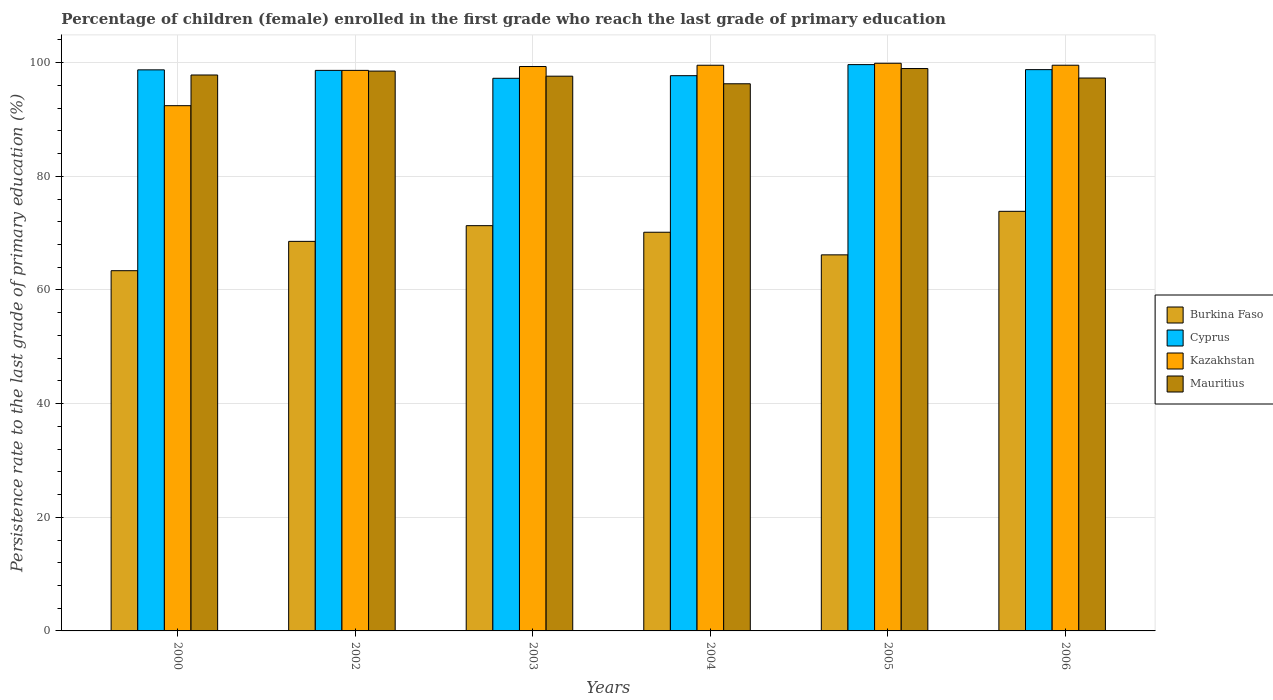How many different coloured bars are there?
Ensure brevity in your answer.  4. How many groups of bars are there?
Offer a terse response. 6. How many bars are there on the 4th tick from the left?
Your response must be concise. 4. What is the persistence rate of children in Mauritius in 2003?
Make the answer very short. 97.62. Across all years, what is the maximum persistence rate of children in Kazakhstan?
Give a very brief answer. 99.9. Across all years, what is the minimum persistence rate of children in Burkina Faso?
Give a very brief answer. 63.39. In which year was the persistence rate of children in Cyprus maximum?
Give a very brief answer. 2005. In which year was the persistence rate of children in Kazakhstan minimum?
Keep it short and to the point. 2000. What is the total persistence rate of children in Kazakhstan in the graph?
Offer a terse response. 589.4. What is the difference between the persistence rate of children in Kazakhstan in 2002 and that in 2006?
Ensure brevity in your answer.  -0.91. What is the difference between the persistence rate of children in Burkina Faso in 2003 and the persistence rate of children in Kazakhstan in 2005?
Your answer should be very brief. -28.58. What is the average persistence rate of children in Burkina Faso per year?
Ensure brevity in your answer.  68.91. In the year 2006, what is the difference between the persistence rate of children in Cyprus and persistence rate of children in Mauritius?
Keep it short and to the point. 1.48. In how many years, is the persistence rate of children in Cyprus greater than 16 %?
Provide a short and direct response. 6. What is the ratio of the persistence rate of children in Mauritius in 2002 to that in 2005?
Give a very brief answer. 1. Is the persistence rate of children in Kazakhstan in 2002 less than that in 2005?
Offer a very short reply. Yes. What is the difference between the highest and the second highest persistence rate of children in Kazakhstan?
Offer a very short reply. 0.35. What is the difference between the highest and the lowest persistence rate of children in Kazakhstan?
Make the answer very short. 7.46. In how many years, is the persistence rate of children in Cyprus greater than the average persistence rate of children in Cyprus taken over all years?
Keep it short and to the point. 4. Is the sum of the persistence rate of children in Cyprus in 2002 and 2006 greater than the maximum persistence rate of children in Mauritius across all years?
Your answer should be compact. Yes. What does the 1st bar from the left in 2002 represents?
Give a very brief answer. Burkina Faso. What does the 4th bar from the right in 2002 represents?
Your answer should be compact. Burkina Faso. Is it the case that in every year, the sum of the persistence rate of children in Kazakhstan and persistence rate of children in Burkina Faso is greater than the persistence rate of children in Mauritius?
Offer a terse response. Yes. Are all the bars in the graph horizontal?
Offer a terse response. No. What is the difference between two consecutive major ticks on the Y-axis?
Give a very brief answer. 20. Are the values on the major ticks of Y-axis written in scientific E-notation?
Ensure brevity in your answer.  No. How many legend labels are there?
Make the answer very short. 4. What is the title of the graph?
Ensure brevity in your answer.  Percentage of children (female) enrolled in the first grade who reach the last grade of primary education. Does "Dominican Republic" appear as one of the legend labels in the graph?
Offer a terse response. No. What is the label or title of the Y-axis?
Give a very brief answer. Persistence rate to the last grade of primary education (%). What is the Persistence rate to the last grade of primary education (%) of Burkina Faso in 2000?
Give a very brief answer. 63.39. What is the Persistence rate to the last grade of primary education (%) of Cyprus in 2000?
Give a very brief answer. 98.74. What is the Persistence rate to the last grade of primary education (%) of Kazakhstan in 2000?
Make the answer very short. 92.43. What is the Persistence rate to the last grade of primary education (%) in Mauritius in 2000?
Your response must be concise. 97.83. What is the Persistence rate to the last grade of primary education (%) in Burkina Faso in 2002?
Make the answer very short. 68.55. What is the Persistence rate to the last grade of primary education (%) in Cyprus in 2002?
Offer a terse response. 98.64. What is the Persistence rate to the last grade of primary education (%) in Kazakhstan in 2002?
Make the answer very short. 98.65. What is the Persistence rate to the last grade of primary education (%) in Mauritius in 2002?
Your answer should be very brief. 98.52. What is the Persistence rate to the last grade of primary education (%) in Burkina Faso in 2003?
Offer a very short reply. 71.32. What is the Persistence rate to the last grade of primary education (%) in Cyprus in 2003?
Make the answer very short. 97.25. What is the Persistence rate to the last grade of primary education (%) of Kazakhstan in 2003?
Your answer should be very brief. 99.32. What is the Persistence rate to the last grade of primary education (%) of Mauritius in 2003?
Give a very brief answer. 97.62. What is the Persistence rate to the last grade of primary education (%) in Burkina Faso in 2004?
Your response must be concise. 70.16. What is the Persistence rate to the last grade of primary education (%) of Cyprus in 2004?
Keep it short and to the point. 97.71. What is the Persistence rate to the last grade of primary education (%) in Kazakhstan in 2004?
Provide a succinct answer. 99.55. What is the Persistence rate to the last grade of primary education (%) of Mauritius in 2004?
Give a very brief answer. 96.29. What is the Persistence rate to the last grade of primary education (%) of Burkina Faso in 2005?
Provide a succinct answer. 66.18. What is the Persistence rate to the last grade of primary education (%) in Cyprus in 2005?
Keep it short and to the point. 99.66. What is the Persistence rate to the last grade of primary education (%) of Kazakhstan in 2005?
Provide a short and direct response. 99.9. What is the Persistence rate to the last grade of primary education (%) in Mauritius in 2005?
Give a very brief answer. 98.97. What is the Persistence rate to the last grade of primary education (%) of Burkina Faso in 2006?
Offer a very short reply. 73.84. What is the Persistence rate to the last grade of primary education (%) of Cyprus in 2006?
Offer a terse response. 98.78. What is the Persistence rate to the last grade of primary education (%) in Kazakhstan in 2006?
Offer a terse response. 99.55. What is the Persistence rate to the last grade of primary education (%) in Mauritius in 2006?
Provide a short and direct response. 97.3. Across all years, what is the maximum Persistence rate to the last grade of primary education (%) in Burkina Faso?
Provide a short and direct response. 73.84. Across all years, what is the maximum Persistence rate to the last grade of primary education (%) in Cyprus?
Provide a succinct answer. 99.66. Across all years, what is the maximum Persistence rate to the last grade of primary education (%) of Kazakhstan?
Provide a short and direct response. 99.9. Across all years, what is the maximum Persistence rate to the last grade of primary education (%) in Mauritius?
Keep it short and to the point. 98.97. Across all years, what is the minimum Persistence rate to the last grade of primary education (%) of Burkina Faso?
Provide a short and direct response. 63.39. Across all years, what is the minimum Persistence rate to the last grade of primary education (%) of Cyprus?
Keep it short and to the point. 97.25. Across all years, what is the minimum Persistence rate to the last grade of primary education (%) in Kazakhstan?
Your response must be concise. 92.43. Across all years, what is the minimum Persistence rate to the last grade of primary education (%) in Mauritius?
Provide a short and direct response. 96.29. What is the total Persistence rate to the last grade of primary education (%) of Burkina Faso in the graph?
Ensure brevity in your answer.  413.45. What is the total Persistence rate to the last grade of primary education (%) in Cyprus in the graph?
Your response must be concise. 590.79. What is the total Persistence rate to the last grade of primary education (%) in Kazakhstan in the graph?
Your answer should be compact. 589.4. What is the total Persistence rate to the last grade of primary education (%) of Mauritius in the graph?
Make the answer very short. 586.54. What is the difference between the Persistence rate to the last grade of primary education (%) in Burkina Faso in 2000 and that in 2002?
Your answer should be very brief. -5.16. What is the difference between the Persistence rate to the last grade of primary education (%) in Cyprus in 2000 and that in 2002?
Provide a short and direct response. 0.09. What is the difference between the Persistence rate to the last grade of primary education (%) of Kazakhstan in 2000 and that in 2002?
Give a very brief answer. -6.21. What is the difference between the Persistence rate to the last grade of primary education (%) of Mauritius in 2000 and that in 2002?
Your answer should be compact. -0.69. What is the difference between the Persistence rate to the last grade of primary education (%) in Burkina Faso in 2000 and that in 2003?
Offer a very short reply. -7.93. What is the difference between the Persistence rate to the last grade of primary education (%) of Cyprus in 2000 and that in 2003?
Provide a short and direct response. 1.48. What is the difference between the Persistence rate to the last grade of primary education (%) of Kazakhstan in 2000 and that in 2003?
Your response must be concise. -6.89. What is the difference between the Persistence rate to the last grade of primary education (%) in Mauritius in 2000 and that in 2003?
Offer a terse response. 0.21. What is the difference between the Persistence rate to the last grade of primary education (%) of Burkina Faso in 2000 and that in 2004?
Your answer should be compact. -6.77. What is the difference between the Persistence rate to the last grade of primary education (%) in Cyprus in 2000 and that in 2004?
Provide a short and direct response. 1.02. What is the difference between the Persistence rate to the last grade of primary education (%) in Kazakhstan in 2000 and that in 2004?
Keep it short and to the point. -7.12. What is the difference between the Persistence rate to the last grade of primary education (%) of Mauritius in 2000 and that in 2004?
Provide a short and direct response. 1.54. What is the difference between the Persistence rate to the last grade of primary education (%) of Burkina Faso in 2000 and that in 2005?
Offer a terse response. -2.79. What is the difference between the Persistence rate to the last grade of primary education (%) of Cyprus in 2000 and that in 2005?
Offer a terse response. -0.92. What is the difference between the Persistence rate to the last grade of primary education (%) in Kazakhstan in 2000 and that in 2005?
Ensure brevity in your answer.  -7.46. What is the difference between the Persistence rate to the last grade of primary education (%) in Mauritius in 2000 and that in 2005?
Your response must be concise. -1.14. What is the difference between the Persistence rate to the last grade of primary education (%) in Burkina Faso in 2000 and that in 2006?
Make the answer very short. -10.45. What is the difference between the Persistence rate to the last grade of primary education (%) in Cyprus in 2000 and that in 2006?
Give a very brief answer. -0.04. What is the difference between the Persistence rate to the last grade of primary education (%) of Kazakhstan in 2000 and that in 2006?
Your answer should be very brief. -7.12. What is the difference between the Persistence rate to the last grade of primary education (%) of Mauritius in 2000 and that in 2006?
Give a very brief answer. 0.53. What is the difference between the Persistence rate to the last grade of primary education (%) in Burkina Faso in 2002 and that in 2003?
Keep it short and to the point. -2.77. What is the difference between the Persistence rate to the last grade of primary education (%) in Cyprus in 2002 and that in 2003?
Offer a terse response. 1.39. What is the difference between the Persistence rate to the last grade of primary education (%) of Kazakhstan in 2002 and that in 2003?
Give a very brief answer. -0.68. What is the difference between the Persistence rate to the last grade of primary education (%) of Mauritius in 2002 and that in 2003?
Your answer should be compact. 0.9. What is the difference between the Persistence rate to the last grade of primary education (%) of Burkina Faso in 2002 and that in 2004?
Your response must be concise. -1.61. What is the difference between the Persistence rate to the last grade of primary education (%) in Cyprus in 2002 and that in 2004?
Your answer should be compact. 0.93. What is the difference between the Persistence rate to the last grade of primary education (%) of Kazakhstan in 2002 and that in 2004?
Offer a terse response. -0.9. What is the difference between the Persistence rate to the last grade of primary education (%) in Mauritius in 2002 and that in 2004?
Your answer should be very brief. 2.23. What is the difference between the Persistence rate to the last grade of primary education (%) in Burkina Faso in 2002 and that in 2005?
Give a very brief answer. 2.37. What is the difference between the Persistence rate to the last grade of primary education (%) of Cyprus in 2002 and that in 2005?
Provide a short and direct response. -1.01. What is the difference between the Persistence rate to the last grade of primary education (%) of Kazakhstan in 2002 and that in 2005?
Offer a very short reply. -1.25. What is the difference between the Persistence rate to the last grade of primary education (%) in Mauritius in 2002 and that in 2005?
Ensure brevity in your answer.  -0.45. What is the difference between the Persistence rate to the last grade of primary education (%) in Burkina Faso in 2002 and that in 2006?
Your answer should be compact. -5.29. What is the difference between the Persistence rate to the last grade of primary education (%) in Cyprus in 2002 and that in 2006?
Offer a very short reply. -0.13. What is the difference between the Persistence rate to the last grade of primary education (%) of Kazakhstan in 2002 and that in 2006?
Provide a succinct answer. -0.91. What is the difference between the Persistence rate to the last grade of primary education (%) in Mauritius in 2002 and that in 2006?
Provide a short and direct response. 1.22. What is the difference between the Persistence rate to the last grade of primary education (%) of Burkina Faso in 2003 and that in 2004?
Offer a terse response. 1.16. What is the difference between the Persistence rate to the last grade of primary education (%) of Cyprus in 2003 and that in 2004?
Offer a very short reply. -0.46. What is the difference between the Persistence rate to the last grade of primary education (%) in Kazakhstan in 2003 and that in 2004?
Your answer should be very brief. -0.23. What is the difference between the Persistence rate to the last grade of primary education (%) in Mauritius in 2003 and that in 2004?
Give a very brief answer. 1.33. What is the difference between the Persistence rate to the last grade of primary education (%) of Burkina Faso in 2003 and that in 2005?
Provide a short and direct response. 5.14. What is the difference between the Persistence rate to the last grade of primary education (%) of Cyprus in 2003 and that in 2005?
Ensure brevity in your answer.  -2.41. What is the difference between the Persistence rate to the last grade of primary education (%) in Kazakhstan in 2003 and that in 2005?
Ensure brevity in your answer.  -0.58. What is the difference between the Persistence rate to the last grade of primary education (%) of Mauritius in 2003 and that in 2005?
Your answer should be very brief. -1.35. What is the difference between the Persistence rate to the last grade of primary education (%) of Burkina Faso in 2003 and that in 2006?
Your answer should be compact. -2.52. What is the difference between the Persistence rate to the last grade of primary education (%) of Cyprus in 2003 and that in 2006?
Provide a short and direct response. -1.52. What is the difference between the Persistence rate to the last grade of primary education (%) of Kazakhstan in 2003 and that in 2006?
Ensure brevity in your answer.  -0.23. What is the difference between the Persistence rate to the last grade of primary education (%) of Mauritius in 2003 and that in 2006?
Make the answer very short. 0.33. What is the difference between the Persistence rate to the last grade of primary education (%) in Burkina Faso in 2004 and that in 2005?
Your answer should be very brief. 3.98. What is the difference between the Persistence rate to the last grade of primary education (%) in Cyprus in 2004 and that in 2005?
Keep it short and to the point. -1.95. What is the difference between the Persistence rate to the last grade of primary education (%) in Kazakhstan in 2004 and that in 2005?
Keep it short and to the point. -0.35. What is the difference between the Persistence rate to the last grade of primary education (%) in Mauritius in 2004 and that in 2005?
Ensure brevity in your answer.  -2.68. What is the difference between the Persistence rate to the last grade of primary education (%) in Burkina Faso in 2004 and that in 2006?
Ensure brevity in your answer.  -3.68. What is the difference between the Persistence rate to the last grade of primary education (%) of Cyprus in 2004 and that in 2006?
Provide a short and direct response. -1.06. What is the difference between the Persistence rate to the last grade of primary education (%) of Kazakhstan in 2004 and that in 2006?
Make the answer very short. -0. What is the difference between the Persistence rate to the last grade of primary education (%) of Mauritius in 2004 and that in 2006?
Offer a very short reply. -1.01. What is the difference between the Persistence rate to the last grade of primary education (%) of Burkina Faso in 2005 and that in 2006?
Make the answer very short. -7.66. What is the difference between the Persistence rate to the last grade of primary education (%) in Cyprus in 2005 and that in 2006?
Keep it short and to the point. 0.88. What is the difference between the Persistence rate to the last grade of primary education (%) in Kazakhstan in 2005 and that in 2006?
Provide a short and direct response. 0.35. What is the difference between the Persistence rate to the last grade of primary education (%) of Mauritius in 2005 and that in 2006?
Offer a terse response. 1.67. What is the difference between the Persistence rate to the last grade of primary education (%) in Burkina Faso in 2000 and the Persistence rate to the last grade of primary education (%) in Cyprus in 2002?
Offer a terse response. -35.25. What is the difference between the Persistence rate to the last grade of primary education (%) of Burkina Faso in 2000 and the Persistence rate to the last grade of primary education (%) of Kazakhstan in 2002?
Give a very brief answer. -35.25. What is the difference between the Persistence rate to the last grade of primary education (%) of Burkina Faso in 2000 and the Persistence rate to the last grade of primary education (%) of Mauritius in 2002?
Ensure brevity in your answer.  -35.13. What is the difference between the Persistence rate to the last grade of primary education (%) of Cyprus in 2000 and the Persistence rate to the last grade of primary education (%) of Kazakhstan in 2002?
Ensure brevity in your answer.  0.09. What is the difference between the Persistence rate to the last grade of primary education (%) of Cyprus in 2000 and the Persistence rate to the last grade of primary education (%) of Mauritius in 2002?
Keep it short and to the point. 0.21. What is the difference between the Persistence rate to the last grade of primary education (%) in Kazakhstan in 2000 and the Persistence rate to the last grade of primary education (%) in Mauritius in 2002?
Keep it short and to the point. -6.09. What is the difference between the Persistence rate to the last grade of primary education (%) of Burkina Faso in 2000 and the Persistence rate to the last grade of primary education (%) of Cyprus in 2003?
Keep it short and to the point. -33.86. What is the difference between the Persistence rate to the last grade of primary education (%) of Burkina Faso in 2000 and the Persistence rate to the last grade of primary education (%) of Kazakhstan in 2003?
Offer a very short reply. -35.93. What is the difference between the Persistence rate to the last grade of primary education (%) in Burkina Faso in 2000 and the Persistence rate to the last grade of primary education (%) in Mauritius in 2003?
Give a very brief answer. -34.23. What is the difference between the Persistence rate to the last grade of primary education (%) in Cyprus in 2000 and the Persistence rate to the last grade of primary education (%) in Kazakhstan in 2003?
Give a very brief answer. -0.59. What is the difference between the Persistence rate to the last grade of primary education (%) in Cyprus in 2000 and the Persistence rate to the last grade of primary education (%) in Mauritius in 2003?
Provide a succinct answer. 1.11. What is the difference between the Persistence rate to the last grade of primary education (%) in Kazakhstan in 2000 and the Persistence rate to the last grade of primary education (%) in Mauritius in 2003?
Offer a terse response. -5.19. What is the difference between the Persistence rate to the last grade of primary education (%) in Burkina Faso in 2000 and the Persistence rate to the last grade of primary education (%) in Cyprus in 2004?
Ensure brevity in your answer.  -34.32. What is the difference between the Persistence rate to the last grade of primary education (%) of Burkina Faso in 2000 and the Persistence rate to the last grade of primary education (%) of Kazakhstan in 2004?
Provide a short and direct response. -36.16. What is the difference between the Persistence rate to the last grade of primary education (%) in Burkina Faso in 2000 and the Persistence rate to the last grade of primary education (%) in Mauritius in 2004?
Make the answer very short. -32.9. What is the difference between the Persistence rate to the last grade of primary education (%) in Cyprus in 2000 and the Persistence rate to the last grade of primary education (%) in Kazakhstan in 2004?
Make the answer very short. -0.81. What is the difference between the Persistence rate to the last grade of primary education (%) of Cyprus in 2000 and the Persistence rate to the last grade of primary education (%) of Mauritius in 2004?
Provide a succinct answer. 2.45. What is the difference between the Persistence rate to the last grade of primary education (%) of Kazakhstan in 2000 and the Persistence rate to the last grade of primary education (%) of Mauritius in 2004?
Your answer should be compact. -3.86. What is the difference between the Persistence rate to the last grade of primary education (%) of Burkina Faso in 2000 and the Persistence rate to the last grade of primary education (%) of Cyprus in 2005?
Make the answer very short. -36.27. What is the difference between the Persistence rate to the last grade of primary education (%) in Burkina Faso in 2000 and the Persistence rate to the last grade of primary education (%) in Kazakhstan in 2005?
Ensure brevity in your answer.  -36.51. What is the difference between the Persistence rate to the last grade of primary education (%) of Burkina Faso in 2000 and the Persistence rate to the last grade of primary education (%) of Mauritius in 2005?
Ensure brevity in your answer.  -35.58. What is the difference between the Persistence rate to the last grade of primary education (%) in Cyprus in 2000 and the Persistence rate to the last grade of primary education (%) in Kazakhstan in 2005?
Offer a terse response. -1.16. What is the difference between the Persistence rate to the last grade of primary education (%) of Cyprus in 2000 and the Persistence rate to the last grade of primary education (%) of Mauritius in 2005?
Give a very brief answer. -0.23. What is the difference between the Persistence rate to the last grade of primary education (%) in Kazakhstan in 2000 and the Persistence rate to the last grade of primary education (%) in Mauritius in 2005?
Keep it short and to the point. -6.54. What is the difference between the Persistence rate to the last grade of primary education (%) of Burkina Faso in 2000 and the Persistence rate to the last grade of primary education (%) of Cyprus in 2006?
Your answer should be very brief. -35.38. What is the difference between the Persistence rate to the last grade of primary education (%) in Burkina Faso in 2000 and the Persistence rate to the last grade of primary education (%) in Kazakhstan in 2006?
Offer a terse response. -36.16. What is the difference between the Persistence rate to the last grade of primary education (%) in Burkina Faso in 2000 and the Persistence rate to the last grade of primary education (%) in Mauritius in 2006?
Your response must be concise. -33.91. What is the difference between the Persistence rate to the last grade of primary education (%) in Cyprus in 2000 and the Persistence rate to the last grade of primary education (%) in Kazakhstan in 2006?
Provide a succinct answer. -0.81. What is the difference between the Persistence rate to the last grade of primary education (%) of Cyprus in 2000 and the Persistence rate to the last grade of primary education (%) of Mauritius in 2006?
Give a very brief answer. 1.44. What is the difference between the Persistence rate to the last grade of primary education (%) in Kazakhstan in 2000 and the Persistence rate to the last grade of primary education (%) in Mauritius in 2006?
Make the answer very short. -4.86. What is the difference between the Persistence rate to the last grade of primary education (%) of Burkina Faso in 2002 and the Persistence rate to the last grade of primary education (%) of Cyprus in 2003?
Provide a short and direct response. -28.7. What is the difference between the Persistence rate to the last grade of primary education (%) in Burkina Faso in 2002 and the Persistence rate to the last grade of primary education (%) in Kazakhstan in 2003?
Your response must be concise. -30.77. What is the difference between the Persistence rate to the last grade of primary education (%) of Burkina Faso in 2002 and the Persistence rate to the last grade of primary education (%) of Mauritius in 2003?
Provide a short and direct response. -29.07. What is the difference between the Persistence rate to the last grade of primary education (%) in Cyprus in 2002 and the Persistence rate to the last grade of primary education (%) in Kazakhstan in 2003?
Give a very brief answer. -0.68. What is the difference between the Persistence rate to the last grade of primary education (%) of Cyprus in 2002 and the Persistence rate to the last grade of primary education (%) of Mauritius in 2003?
Your answer should be very brief. 1.02. What is the difference between the Persistence rate to the last grade of primary education (%) of Kazakhstan in 2002 and the Persistence rate to the last grade of primary education (%) of Mauritius in 2003?
Provide a short and direct response. 1.02. What is the difference between the Persistence rate to the last grade of primary education (%) of Burkina Faso in 2002 and the Persistence rate to the last grade of primary education (%) of Cyprus in 2004?
Your answer should be compact. -29.16. What is the difference between the Persistence rate to the last grade of primary education (%) in Burkina Faso in 2002 and the Persistence rate to the last grade of primary education (%) in Kazakhstan in 2004?
Your answer should be very brief. -31. What is the difference between the Persistence rate to the last grade of primary education (%) of Burkina Faso in 2002 and the Persistence rate to the last grade of primary education (%) of Mauritius in 2004?
Provide a short and direct response. -27.74. What is the difference between the Persistence rate to the last grade of primary education (%) of Cyprus in 2002 and the Persistence rate to the last grade of primary education (%) of Kazakhstan in 2004?
Your response must be concise. -0.91. What is the difference between the Persistence rate to the last grade of primary education (%) in Cyprus in 2002 and the Persistence rate to the last grade of primary education (%) in Mauritius in 2004?
Your response must be concise. 2.36. What is the difference between the Persistence rate to the last grade of primary education (%) in Kazakhstan in 2002 and the Persistence rate to the last grade of primary education (%) in Mauritius in 2004?
Make the answer very short. 2.36. What is the difference between the Persistence rate to the last grade of primary education (%) in Burkina Faso in 2002 and the Persistence rate to the last grade of primary education (%) in Cyprus in 2005?
Make the answer very short. -31.11. What is the difference between the Persistence rate to the last grade of primary education (%) of Burkina Faso in 2002 and the Persistence rate to the last grade of primary education (%) of Kazakhstan in 2005?
Ensure brevity in your answer.  -31.34. What is the difference between the Persistence rate to the last grade of primary education (%) of Burkina Faso in 2002 and the Persistence rate to the last grade of primary education (%) of Mauritius in 2005?
Provide a succinct answer. -30.42. What is the difference between the Persistence rate to the last grade of primary education (%) of Cyprus in 2002 and the Persistence rate to the last grade of primary education (%) of Kazakhstan in 2005?
Ensure brevity in your answer.  -1.25. What is the difference between the Persistence rate to the last grade of primary education (%) in Cyprus in 2002 and the Persistence rate to the last grade of primary education (%) in Mauritius in 2005?
Provide a short and direct response. -0.33. What is the difference between the Persistence rate to the last grade of primary education (%) of Kazakhstan in 2002 and the Persistence rate to the last grade of primary education (%) of Mauritius in 2005?
Keep it short and to the point. -0.32. What is the difference between the Persistence rate to the last grade of primary education (%) of Burkina Faso in 2002 and the Persistence rate to the last grade of primary education (%) of Cyprus in 2006?
Make the answer very short. -30.22. What is the difference between the Persistence rate to the last grade of primary education (%) in Burkina Faso in 2002 and the Persistence rate to the last grade of primary education (%) in Kazakhstan in 2006?
Ensure brevity in your answer.  -31. What is the difference between the Persistence rate to the last grade of primary education (%) in Burkina Faso in 2002 and the Persistence rate to the last grade of primary education (%) in Mauritius in 2006?
Keep it short and to the point. -28.74. What is the difference between the Persistence rate to the last grade of primary education (%) of Cyprus in 2002 and the Persistence rate to the last grade of primary education (%) of Kazakhstan in 2006?
Offer a very short reply. -0.91. What is the difference between the Persistence rate to the last grade of primary education (%) in Cyprus in 2002 and the Persistence rate to the last grade of primary education (%) in Mauritius in 2006?
Your answer should be compact. 1.35. What is the difference between the Persistence rate to the last grade of primary education (%) in Kazakhstan in 2002 and the Persistence rate to the last grade of primary education (%) in Mauritius in 2006?
Ensure brevity in your answer.  1.35. What is the difference between the Persistence rate to the last grade of primary education (%) of Burkina Faso in 2003 and the Persistence rate to the last grade of primary education (%) of Cyprus in 2004?
Provide a short and direct response. -26.39. What is the difference between the Persistence rate to the last grade of primary education (%) in Burkina Faso in 2003 and the Persistence rate to the last grade of primary education (%) in Kazakhstan in 2004?
Your answer should be compact. -28.23. What is the difference between the Persistence rate to the last grade of primary education (%) of Burkina Faso in 2003 and the Persistence rate to the last grade of primary education (%) of Mauritius in 2004?
Your answer should be compact. -24.97. What is the difference between the Persistence rate to the last grade of primary education (%) in Cyprus in 2003 and the Persistence rate to the last grade of primary education (%) in Kazakhstan in 2004?
Keep it short and to the point. -2.3. What is the difference between the Persistence rate to the last grade of primary education (%) in Cyprus in 2003 and the Persistence rate to the last grade of primary education (%) in Mauritius in 2004?
Make the answer very short. 0.96. What is the difference between the Persistence rate to the last grade of primary education (%) of Kazakhstan in 2003 and the Persistence rate to the last grade of primary education (%) of Mauritius in 2004?
Provide a succinct answer. 3.03. What is the difference between the Persistence rate to the last grade of primary education (%) in Burkina Faso in 2003 and the Persistence rate to the last grade of primary education (%) in Cyprus in 2005?
Provide a succinct answer. -28.34. What is the difference between the Persistence rate to the last grade of primary education (%) of Burkina Faso in 2003 and the Persistence rate to the last grade of primary education (%) of Kazakhstan in 2005?
Offer a terse response. -28.58. What is the difference between the Persistence rate to the last grade of primary education (%) in Burkina Faso in 2003 and the Persistence rate to the last grade of primary education (%) in Mauritius in 2005?
Keep it short and to the point. -27.65. What is the difference between the Persistence rate to the last grade of primary education (%) of Cyprus in 2003 and the Persistence rate to the last grade of primary education (%) of Kazakhstan in 2005?
Your answer should be compact. -2.65. What is the difference between the Persistence rate to the last grade of primary education (%) of Cyprus in 2003 and the Persistence rate to the last grade of primary education (%) of Mauritius in 2005?
Offer a terse response. -1.72. What is the difference between the Persistence rate to the last grade of primary education (%) of Kazakhstan in 2003 and the Persistence rate to the last grade of primary education (%) of Mauritius in 2005?
Provide a short and direct response. 0.35. What is the difference between the Persistence rate to the last grade of primary education (%) of Burkina Faso in 2003 and the Persistence rate to the last grade of primary education (%) of Cyprus in 2006?
Your answer should be compact. -27.46. What is the difference between the Persistence rate to the last grade of primary education (%) in Burkina Faso in 2003 and the Persistence rate to the last grade of primary education (%) in Kazakhstan in 2006?
Your answer should be very brief. -28.23. What is the difference between the Persistence rate to the last grade of primary education (%) of Burkina Faso in 2003 and the Persistence rate to the last grade of primary education (%) of Mauritius in 2006?
Make the answer very short. -25.98. What is the difference between the Persistence rate to the last grade of primary education (%) of Cyprus in 2003 and the Persistence rate to the last grade of primary education (%) of Kazakhstan in 2006?
Offer a very short reply. -2.3. What is the difference between the Persistence rate to the last grade of primary education (%) in Cyprus in 2003 and the Persistence rate to the last grade of primary education (%) in Mauritius in 2006?
Give a very brief answer. -0.05. What is the difference between the Persistence rate to the last grade of primary education (%) in Kazakhstan in 2003 and the Persistence rate to the last grade of primary education (%) in Mauritius in 2006?
Keep it short and to the point. 2.02. What is the difference between the Persistence rate to the last grade of primary education (%) in Burkina Faso in 2004 and the Persistence rate to the last grade of primary education (%) in Cyprus in 2005?
Your response must be concise. -29.5. What is the difference between the Persistence rate to the last grade of primary education (%) of Burkina Faso in 2004 and the Persistence rate to the last grade of primary education (%) of Kazakhstan in 2005?
Provide a succinct answer. -29.74. What is the difference between the Persistence rate to the last grade of primary education (%) in Burkina Faso in 2004 and the Persistence rate to the last grade of primary education (%) in Mauritius in 2005?
Offer a very short reply. -28.81. What is the difference between the Persistence rate to the last grade of primary education (%) in Cyprus in 2004 and the Persistence rate to the last grade of primary education (%) in Kazakhstan in 2005?
Give a very brief answer. -2.19. What is the difference between the Persistence rate to the last grade of primary education (%) of Cyprus in 2004 and the Persistence rate to the last grade of primary education (%) of Mauritius in 2005?
Ensure brevity in your answer.  -1.26. What is the difference between the Persistence rate to the last grade of primary education (%) in Kazakhstan in 2004 and the Persistence rate to the last grade of primary education (%) in Mauritius in 2005?
Your response must be concise. 0.58. What is the difference between the Persistence rate to the last grade of primary education (%) of Burkina Faso in 2004 and the Persistence rate to the last grade of primary education (%) of Cyprus in 2006?
Provide a succinct answer. -28.62. What is the difference between the Persistence rate to the last grade of primary education (%) of Burkina Faso in 2004 and the Persistence rate to the last grade of primary education (%) of Kazakhstan in 2006?
Provide a succinct answer. -29.39. What is the difference between the Persistence rate to the last grade of primary education (%) in Burkina Faso in 2004 and the Persistence rate to the last grade of primary education (%) in Mauritius in 2006?
Your answer should be compact. -27.14. What is the difference between the Persistence rate to the last grade of primary education (%) of Cyprus in 2004 and the Persistence rate to the last grade of primary education (%) of Kazakhstan in 2006?
Offer a very short reply. -1.84. What is the difference between the Persistence rate to the last grade of primary education (%) of Cyprus in 2004 and the Persistence rate to the last grade of primary education (%) of Mauritius in 2006?
Give a very brief answer. 0.41. What is the difference between the Persistence rate to the last grade of primary education (%) of Kazakhstan in 2004 and the Persistence rate to the last grade of primary education (%) of Mauritius in 2006?
Offer a very short reply. 2.25. What is the difference between the Persistence rate to the last grade of primary education (%) in Burkina Faso in 2005 and the Persistence rate to the last grade of primary education (%) in Cyprus in 2006?
Offer a very short reply. -32.6. What is the difference between the Persistence rate to the last grade of primary education (%) of Burkina Faso in 2005 and the Persistence rate to the last grade of primary education (%) of Kazakhstan in 2006?
Ensure brevity in your answer.  -33.37. What is the difference between the Persistence rate to the last grade of primary education (%) of Burkina Faso in 2005 and the Persistence rate to the last grade of primary education (%) of Mauritius in 2006?
Provide a succinct answer. -31.12. What is the difference between the Persistence rate to the last grade of primary education (%) of Cyprus in 2005 and the Persistence rate to the last grade of primary education (%) of Kazakhstan in 2006?
Your answer should be very brief. 0.11. What is the difference between the Persistence rate to the last grade of primary education (%) in Cyprus in 2005 and the Persistence rate to the last grade of primary education (%) in Mauritius in 2006?
Keep it short and to the point. 2.36. What is the difference between the Persistence rate to the last grade of primary education (%) in Kazakhstan in 2005 and the Persistence rate to the last grade of primary education (%) in Mauritius in 2006?
Keep it short and to the point. 2.6. What is the average Persistence rate to the last grade of primary education (%) of Burkina Faso per year?
Ensure brevity in your answer.  68.91. What is the average Persistence rate to the last grade of primary education (%) of Cyprus per year?
Provide a short and direct response. 98.46. What is the average Persistence rate to the last grade of primary education (%) in Kazakhstan per year?
Your answer should be compact. 98.23. What is the average Persistence rate to the last grade of primary education (%) of Mauritius per year?
Offer a very short reply. 97.76. In the year 2000, what is the difference between the Persistence rate to the last grade of primary education (%) of Burkina Faso and Persistence rate to the last grade of primary education (%) of Cyprus?
Ensure brevity in your answer.  -35.34. In the year 2000, what is the difference between the Persistence rate to the last grade of primary education (%) of Burkina Faso and Persistence rate to the last grade of primary education (%) of Kazakhstan?
Your answer should be compact. -29.04. In the year 2000, what is the difference between the Persistence rate to the last grade of primary education (%) in Burkina Faso and Persistence rate to the last grade of primary education (%) in Mauritius?
Make the answer very short. -34.44. In the year 2000, what is the difference between the Persistence rate to the last grade of primary education (%) in Cyprus and Persistence rate to the last grade of primary education (%) in Kazakhstan?
Offer a terse response. 6.3. In the year 2000, what is the difference between the Persistence rate to the last grade of primary education (%) of Cyprus and Persistence rate to the last grade of primary education (%) of Mauritius?
Provide a succinct answer. 0.9. In the year 2000, what is the difference between the Persistence rate to the last grade of primary education (%) of Kazakhstan and Persistence rate to the last grade of primary education (%) of Mauritius?
Make the answer very short. -5.4. In the year 2002, what is the difference between the Persistence rate to the last grade of primary education (%) in Burkina Faso and Persistence rate to the last grade of primary education (%) in Cyprus?
Your answer should be very brief. -30.09. In the year 2002, what is the difference between the Persistence rate to the last grade of primary education (%) in Burkina Faso and Persistence rate to the last grade of primary education (%) in Kazakhstan?
Ensure brevity in your answer.  -30.09. In the year 2002, what is the difference between the Persistence rate to the last grade of primary education (%) of Burkina Faso and Persistence rate to the last grade of primary education (%) of Mauritius?
Offer a terse response. -29.97. In the year 2002, what is the difference between the Persistence rate to the last grade of primary education (%) in Cyprus and Persistence rate to the last grade of primary education (%) in Kazakhstan?
Make the answer very short. -0. In the year 2002, what is the difference between the Persistence rate to the last grade of primary education (%) of Cyprus and Persistence rate to the last grade of primary education (%) of Mauritius?
Your answer should be compact. 0.12. In the year 2002, what is the difference between the Persistence rate to the last grade of primary education (%) in Kazakhstan and Persistence rate to the last grade of primary education (%) in Mauritius?
Make the answer very short. 0.12. In the year 2003, what is the difference between the Persistence rate to the last grade of primary education (%) of Burkina Faso and Persistence rate to the last grade of primary education (%) of Cyprus?
Provide a succinct answer. -25.93. In the year 2003, what is the difference between the Persistence rate to the last grade of primary education (%) of Burkina Faso and Persistence rate to the last grade of primary education (%) of Kazakhstan?
Provide a short and direct response. -28. In the year 2003, what is the difference between the Persistence rate to the last grade of primary education (%) of Burkina Faso and Persistence rate to the last grade of primary education (%) of Mauritius?
Your response must be concise. -26.3. In the year 2003, what is the difference between the Persistence rate to the last grade of primary education (%) of Cyprus and Persistence rate to the last grade of primary education (%) of Kazakhstan?
Provide a short and direct response. -2.07. In the year 2003, what is the difference between the Persistence rate to the last grade of primary education (%) in Cyprus and Persistence rate to the last grade of primary education (%) in Mauritius?
Your response must be concise. -0.37. In the year 2003, what is the difference between the Persistence rate to the last grade of primary education (%) in Kazakhstan and Persistence rate to the last grade of primary education (%) in Mauritius?
Your answer should be compact. 1.7. In the year 2004, what is the difference between the Persistence rate to the last grade of primary education (%) of Burkina Faso and Persistence rate to the last grade of primary education (%) of Cyprus?
Ensure brevity in your answer.  -27.55. In the year 2004, what is the difference between the Persistence rate to the last grade of primary education (%) in Burkina Faso and Persistence rate to the last grade of primary education (%) in Kazakhstan?
Ensure brevity in your answer.  -29.39. In the year 2004, what is the difference between the Persistence rate to the last grade of primary education (%) of Burkina Faso and Persistence rate to the last grade of primary education (%) of Mauritius?
Give a very brief answer. -26.13. In the year 2004, what is the difference between the Persistence rate to the last grade of primary education (%) of Cyprus and Persistence rate to the last grade of primary education (%) of Kazakhstan?
Offer a very short reply. -1.84. In the year 2004, what is the difference between the Persistence rate to the last grade of primary education (%) of Cyprus and Persistence rate to the last grade of primary education (%) of Mauritius?
Give a very brief answer. 1.42. In the year 2004, what is the difference between the Persistence rate to the last grade of primary education (%) in Kazakhstan and Persistence rate to the last grade of primary education (%) in Mauritius?
Offer a very short reply. 3.26. In the year 2005, what is the difference between the Persistence rate to the last grade of primary education (%) of Burkina Faso and Persistence rate to the last grade of primary education (%) of Cyprus?
Make the answer very short. -33.48. In the year 2005, what is the difference between the Persistence rate to the last grade of primary education (%) of Burkina Faso and Persistence rate to the last grade of primary education (%) of Kazakhstan?
Your response must be concise. -33.72. In the year 2005, what is the difference between the Persistence rate to the last grade of primary education (%) in Burkina Faso and Persistence rate to the last grade of primary education (%) in Mauritius?
Ensure brevity in your answer.  -32.79. In the year 2005, what is the difference between the Persistence rate to the last grade of primary education (%) in Cyprus and Persistence rate to the last grade of primary education (%) in Kazakhstan?
Your response must be concise. -0.24. In the year 2005, what is the difference between the Persistence rate to the last grade of primary education (%) in Cyprus and Persistence rate to the last grade of primary education (%) in Mauritius?
Your answer should be very brief. 0.69. In the year 2005, what is the difference between the Persistence rate to the last grade of primary education (%) in Kazakhstan and Persistence rate to the last grade of primary education (%) in Mauritius?
Keep it short and to the point. 0.93. In the year 2006, what is the difference between the Persistence rate to the last grade of primary education (%) of Burkina Faso and Persistence rate to the last grade of primary education (%) of Cyprus?
Your answer should be compact. -24.93. In the year 2006, what is the difference between the Persistence rate to the last grade of primary education (%) of Burkina Faso and Persistence rate to the last grade of primary education (%) of Kazakhstan?
Your response must be concise. -25.71. In the year 2006, what is the difference between the Persistence rate to the last grade of primary education (%) in Burkina Faso and Persistence rate to the last grade of primary education (%) in Mauritius?
Provide a succinct answer. -23.46. In the year 2006, what is the difference between the Persistence rate to the last grade of primary education (%) of Cyprus and Persistence rate to the last grade of primary education (%) of Kazakhstan?
Your response must be concise. -0.77. In the year 2006, what is the difference between the Persistence rate to the last grade of primary education (%) in Cyprus and Persistence rate to the last grade of primary education (%) in Mauritius?
Offer a very short reply. 1.48. In the year 2006, what is the difference between the Persistence rate to the last grade of primary education (%) of Kazakhstan and Persistence rate to the last grade of primary education (%) of Mauritius?
Make the answer very short. 2.25. What is the ratio of the Persistence rate to the last grade of primary education (%) in Burkina Faso in 2000 to that in 2002?
Provide a short and direct response. 0.92. What is the ratio of the Persistence rate to the last grade of primary education (%) in Cyprus in 2000 to that in 2002?
Your answer should be compact. 1. What is the ratio of the Persistence rate to the last grade of primary education (%) of Kazakhstan in 2000 to that in 2002?
Ensure brevity in your answer.  0.94. What is the ratio of the Persistence rate to the last grade of primary education (%) in Cyprus in 2000 to that in 2003?
Your response must be concise. 1.02. What is the ratio of the Persistence rate to the last grade of primary education (%) in Kazakhstan in 2000 to that in 2003?
Give a very brief answer. 0.93. What is the ratio of the Persistence rate to the last grade of primary education (%) of Burkina Faso in 2000 to that in 2004?
Provide a short and direct response. 0.9. What is the ratio of the Persistence rate to the last grade of primary education (%) of Cyprus in 2000 to that in 2004?
Your answer should be very brief. 1.01. What is the ratio of the Persistence rate to the last grade of primary education (%) of Kazakhstan in 2000 to that in 2004?
Offer a very short reply. 0.93. What is the ratio of the Persistence rate to the last grade of primary education (%) in Burkina Faso in 2000 to that in 2005?
Your response must be concise. 0.96. What is the ratio of the Persistence rate to the last grade of primary education (%) in Kazakhstan in 2000 to that in 2005?
Make the answer very short. 0.93. What is the ratio of the Persistence rate to the last grade of primary education (%) of Mauritius in 2000 to that in 2005?
Offer a terse response. 0.99. What is the ratio of the Persistence rate to the last grade of primary education (%) in Burkina Faso in 2000 to that in 2006?
Your response must be concise. 0.86. What is the ratio of the Persistence rate to the last grade of primary education (%) in Cyprus in 2000 to that in 2006?
Give a very brief answer. 1. What is the ratio of the Persistence rate to the last grade of primary education (%) of Kazakhstan in 2000 to that in 2006?
Ensure brevity in your answer.  0.93. What is the ratio of the Persistence rate to the last grade of primary education (%) of Mauritius in 2000 to that in 2006?
Provide a succinct answer. 1.01. What is the ratio of the Persistence rate to the last grade of primary education (%) in Burkina Faso in 2002 to that in 2003?
Keep it short and to the point. 0.96. What is the ratio of the Persistence rate to the last grade of primary education (%) of Cyprus in 2002 to that in 2003?
Make the answer very short. 1.01. What is the ratio of the Persistence rate to the last grade of primary education (%) of Kazakhstan in 2002 to that in 2003?
Provide a succinct answer. 0.99. What is the ratio of the Persistence rate to the last grade of primary education (%) in Mauritius in 2002 to that in 2003?
Offer a very short reply. 1.01. What is the ratio of the Persistence rate to the last grade of primary education (%) in Burkina Faso in 2002 to that in 2004?
Ensure brevity in your answer.  0.98. What is the ratio of the Persistence rate to the last grade of primary education (%) in Cyprus in 2002 to that in 2004?
Offer a very short reply. 1.01. What is the ratio of the Persistence rate to the last grade of primary education (%) of Kazakhstan in 2002 to that in 2004?
Make the answer very short. 0.99. What is the ratio of the Persistence rate to the last grade of primary education (%) of Mauritius in 2002 to that in 2004?
Ensure brevity in your answer.  1.02. What is the ratio of the Persistence rate to the last grade of primary education (%) in Burkina Faso in 2002 to that in 2005?
Provide a succinct answer. 1.04. What is the ratio of the Persistence rate to the last grade of primary education (%) of Kazakhstan in 2002 to that in 2005?
Ensure brevity in your answer.  0.99. What is the ratio of the Persistence rate to the last grade of primary education (%) in Burkina Faso in 2002 to that in 2006?
Make the answer very short. 0.93. What is the ratio of the Persistence rate to the last grade of primary education (%) in Cyprus in 2002 to that in 2006?
Offer a terse response. 1. What is the ratio of the Persistence rate to the last grade of primary education (%) of Kazakhstan in 2002 to that in 2006?
Your answer should be compact. 0.99. What is the ratio of the Persistence rate to the last grade of primary education (%) in Mauritius in 2002 to that in 2006?
Provide a short and direct response. 1.01. What is the ratio of the Persistence rate to the last grade of primary education (%) of Burkina Faso in 2003 to that in 2004?
Keep it short and to the point. 1.02. What is the ratio of the Persistence rate to the last grade of primary education (%) of Cyprus in 2003 to that in 2004?
Offer a very short reply. 1. What is the ratio of the Persistence rate to the last grade of primary education (%) in Kazakhstan in 2003 to that in 2004?
Ensure brevity in your answer.  1. What is the ratio of the Persistence rate to the last grade of primary education (%) in Mauritius in 2003 to that in 2004?
Provide a short and direct response. 1.01. What is the ratio of the Persistence rate to the last grade of primary education (%) in Burkina Faso in 2003 to that in 2005?
Provide a succinct answer. 1.08. What is the ratio of the Persistence rate to the last grade of primary education (%) in Cyprus in 2003 to that in 2005?
Provide a short and direct response. 0.98. What is the ratio of the Persistence rate to the last grade of primary education (%) of Mauritius in 2003 to that in 2005?
Your answer should be compact. 0.99. What is the ratio of the Persistence rate to the last grade of primary education (%) of Burkina Faso in 2003 to that in 2006?
Offer a terse response. 0.97. What is the ratio of the Persistence rate to the last grade of primary education (%) in Cyprus in 2003 to that in 2006?
Offer a very short reply. 0.98. What is the ratio of the Persistence rate to the last grade of primary education (%) of Kazakhstan in 2003 to that in 2006?
Ensure brevity in your answer.  1. What is the ratio of the Persistence rate to the last grade of primary education (%) in Mauritius in 2003 to that in 2006?
Your answer should be compact. 1. What is the ratio of the Persistence rate to the last grade of primary education (%) of Burkina Faso in 2004 to that in 2005?
Give a very brief answer. 1.06. What is the ratio of the Persistence rate to the last grade of primary education (%) of Cyprus in 2004 to that in 2005?
Provide a short and direct response. 0.98. What is the ratio of the Persistence rate to the last grade of primary education (%) in Kazakhstan in 2004 to that in 2005?
Your answer should be compact. 1. What is the ratio of the Persistence rate to the last grade of primary education (%) of Mauritius in 2004 to that in 2005?
Your answer should be compact. 0.97. What is the ratio of the Persistence rate to the last grade of primary education (%) in Burkina Faso in 2004 to that in 2006?
Offer a very short reply. 0.95. What is the ratio of the Persistence rate to the last grade of primary education (%) in Kazakhstan in 2004 to that in 2006?
Make the answer very short. 1. What is the ratio of the Persistence rate to the last grade of primary education (%) of Mauritius in 2004 to that in 2006?
Provide a short and direct response. 0.99. What is the ratio of the Persistence rate to the last grade of primary education (%) in Burkina Faso in 2005 to that in 2006?
Make the answer very short. 0.9. What is the ratio of the Persistence rate to the last grade of primary education (%) of Cyprus in 2005 to that in 2006?
Your answer should be compact. 1.01. What is the ratio of the Persistence rate to the last grade of primary education (%) in Mauritius in 2005 to that in 2006?
Your response must be concise. 1.02. What is the difference between the highest and the second highest Persistence rate to the last grade of primary education (%) of Burkina Faso?
Ensure brevity in your answer.  2.52. What is the difference between the highest and the second highest Persistence rate to the last grade of primary education (%) in Cyprus?
Offer a very short reply. 0.88. What is the difference between the highest and the second highest Persistence rate to the last grade of primary education (%) of Kazakhstan?
Make the answer very short. 0.35. What is the difference between the highest and the second highest Persistence rate to the last grade of primary education (%) in Mauritius?
Make the answer very short. 0.45. What is the difference between the highest and the lowest Persistence rate to the last grade of primary education (%) of Burkina Faso?
Offer a terse response. 10.45. What is the difference between the highest and the lowest Persistence rate to the last grade of primary education (%) in Cyprus?
Your answer should be very brief. 2.41. What is the difference between the highest and the lowest Persistence rate to the last grade of primary education (%) in Kazakhstan?
Ensure brevity in your answer.  7.46. What is the difference between the highest and the lowest Persistence rate to the last grade of primary education (%) in Mauritius?
Keep it short and to the point. 2.68. 